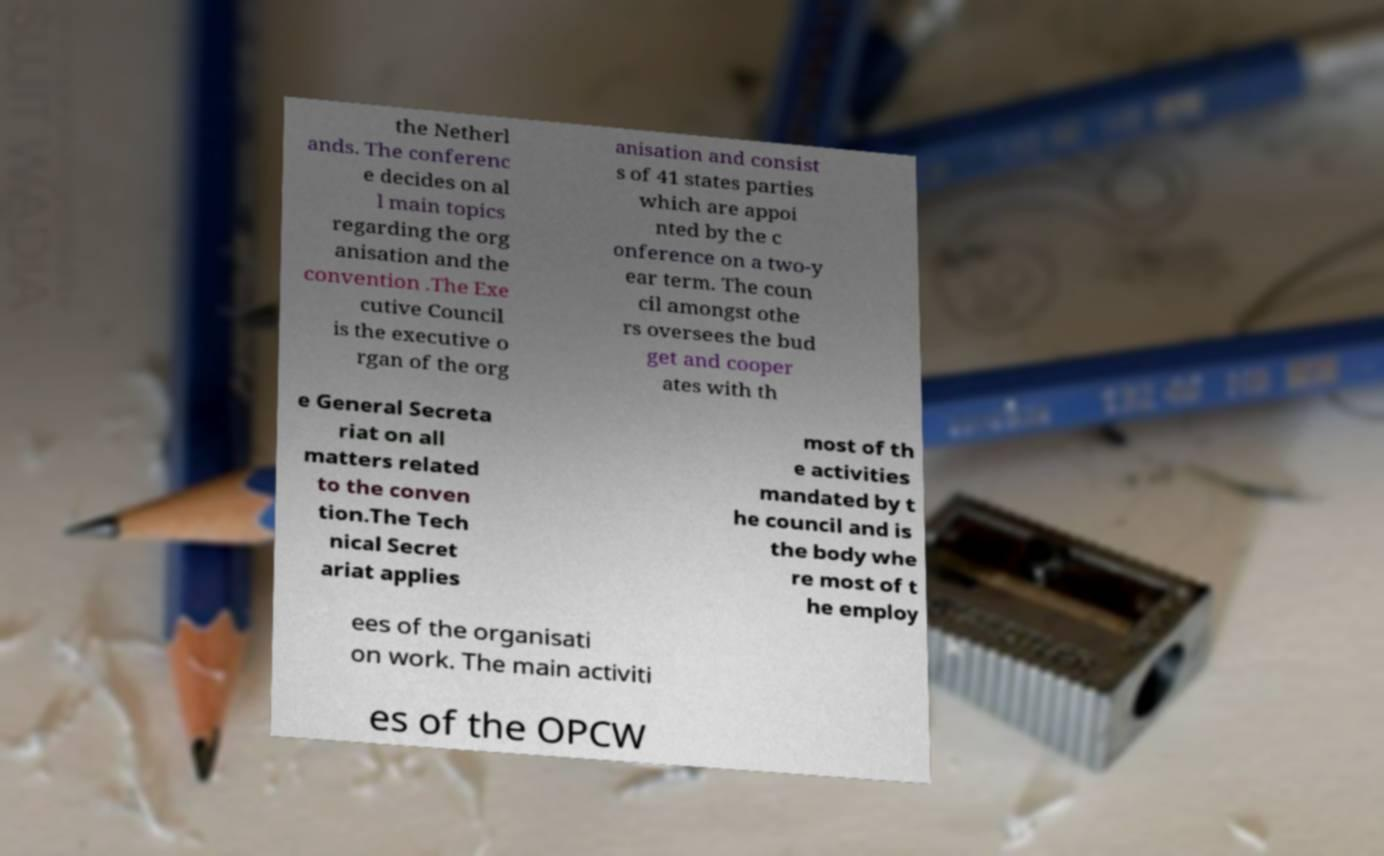What messages or text are displayed in this image? I need them in a readable, typed format. the Netherl ands. The conferenc e decides on al l main topics regarding the org anisation and the convention .The Exe cutive Council is the executive o rgan of the org anisation and consist s of 41 states parties which are appoi nted by the c onference on a two-y ear term. The coun cil amongst othe rs oversees the bud get and cooper ates with th e General Secreta riat on all matters related to the conven tion.The Tech nical Secret ariat applies most of th e activities mandated by t he council and is the body whe re most of t he employ ees of the organisati on work. The main activiti es of the OPCW 